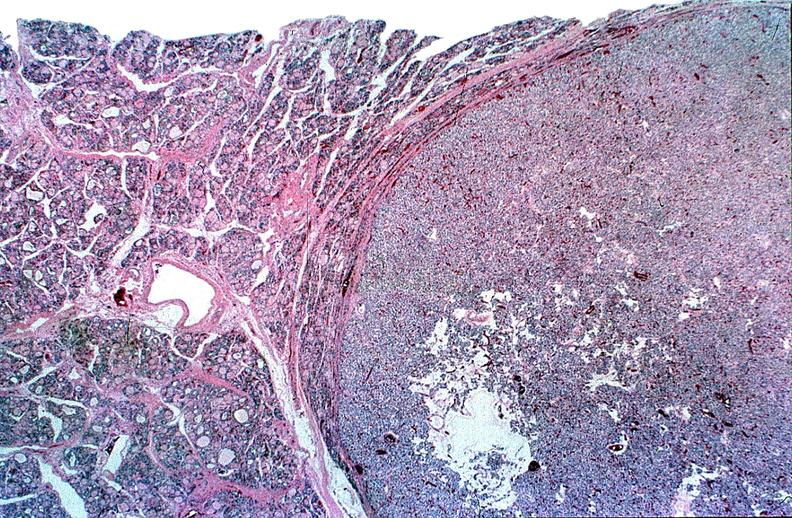does this image show thyroid, follicular ademona?
Answer the question using a single word or phrase. Yes 